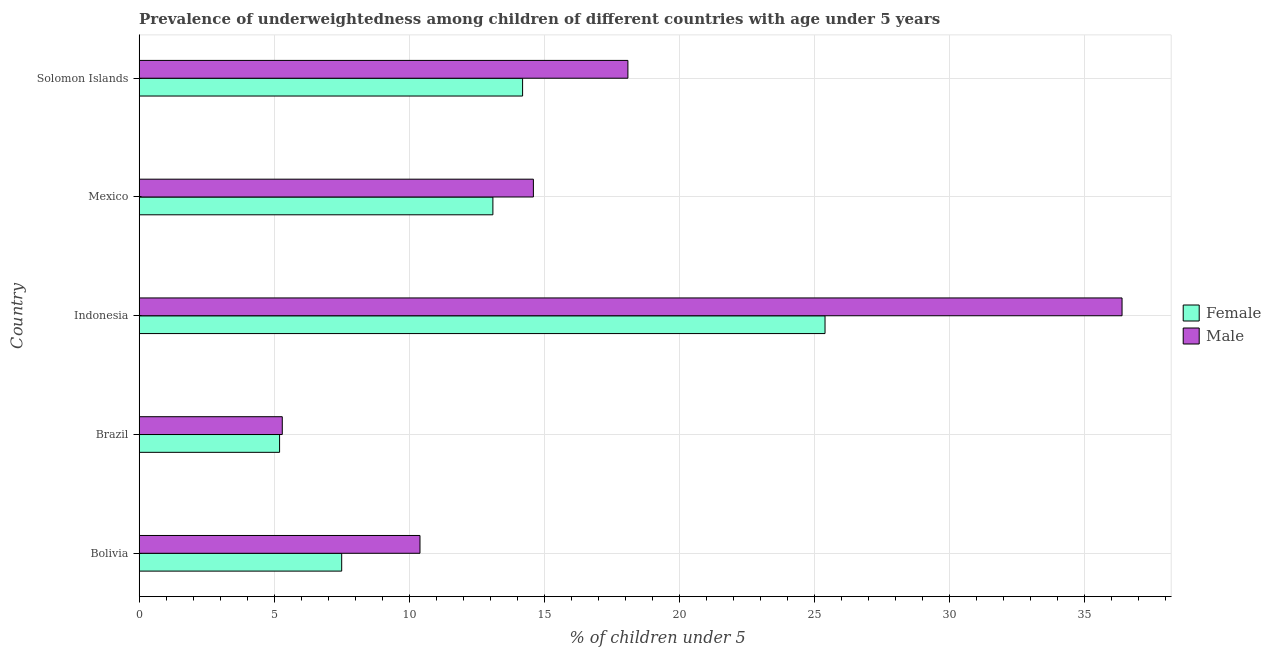Are the number of bars per tick equal to the number of legend labels?
Offer a terse response. Yes. Are the number of bars on each tick of the Y-axis equal?
Give a very brief answer. Yes. How many bars are there on the 1st tick from the top?
Ensure brevity in your answer.  2. How many bars are there on the 1st tick from the bottom?
Your answer should be compact. 2. In how many cases, is the number of bars for a given country not equal to the number of legend labels?
Ensure brevity in your answer.  0. What is the percentage of underweighted male children in Bolivia?
Make the answer very short. 10.4. Across all countries, what is the maximum percentage of underweighted male children?
Make the answer very short. 36.4. Across all countries, what is the minimum percentage of underweighted male children?
Provide a short and direct response. 5.3. What is the total percentage of underweighted female children in the graph?
Keep it short and to the point. 65.4. What is the difference between the percentage of underweighted male children in Mexico and the percentage of underweighted female children in Solomon Islands?
Offer a very short reply. 0.4. What is the average percentage of underweighted male children per country?
Offer a terse response. 16.96. In how many countries, is the percentage of underweighted male children greater than 34 %?
Keep it short and to the point. 1. What is the ratio of the percentage of underweighted female children in Bolivia to that in Brazil?
Ensure brevity in your answer.  1.44. Is the difference between the percentage of underweighted male children in Indonesia and Solomon Islands greater than the difference between the percentage of underweighted female children in Indonesia and Solomon Islands?
Your answer should be very brief. Yes. What is the difference between the highest and the second highest percentage of underweighted male children?
Your answer should be compact. 18.3. What is the difference between the highest and the lowest percentage of underweighted female children?
Your response must be concise. 20.2. In how many countries, is the percentage of underweighted male children greater than the average percentage of underweighted male children taken over all countries?
Give a very brief answer. 2. What does the 1st bar from the bottom in Indonesia represents?
Ensure brevity in your answer.  Female. How many bars are there?
Provide a succinct answer. 10. Are all the bars in the graph horizontal?
Provide a short and direct response. Yes. How many legend labels are there?
Offer a terse response. 2. What is the title of the graph?
Keep it short and to the point. Prevalence of underweightedness among children of different countries with age under 5 years. What is the label or title of the X-axis?
Make the answer very short.  % of children under 5. What is the  % of children under 5 of Male in Bolivia?
Offer a terse response. 10.4. What is the  % of children under 5 in Female in Brazil?
Your response must be concise. 5.2. What is the  % of children under 5 of Male in Brazil?
Your answer should be compact. 5.3. What is the  % of children under 5 of Female in Indonesia?
Your response must be concise. 25.4. What is the  % of children under 5 in Male in Indonesia?
Keep it short and to the point. 36.4. What is the  % of children under 5 in Female in Mexico?
Make the answer very short. 13.1. What is the  % of children under 5 of Male in Mexico?
Give a very brief answer. 14.6. What is the  % of children under 5 of Female in Solomon Islands?
Make the answer very short. 14.2. What is the  % of children under 5 in Male in Solomon Islands?
Your answer should be very brief. 18.1. Across all countries, what is the maximum  % of children under 5 of Female?
Give a very brief answer. 25.4. Across all countries, what is the maximum  % of children under 5 in Male?
Offer a very short reply. 36.4. Across all countries, what is the minimum  % of children under 5 of Female?
Your answer should be compact. 5.2. Across all countries, what is the minimum  % of children under 5 in Male?
Offer a terse response. 5.3. What is the total  % of children under 5 in Female in the graph?
Your answer should be compact. 65.4. What is the total  % of children under 5 in Male in the graph?
Offer a very short reply. 84.8. What is the difference between the  % of children under 5 in Female in Bolivia and that in Indonesia?
Your answer should be very brief. -17.9. What is the difference between the  % of children under 5 in Female in Bolivia and that in Solomon Islands?
Your answer should be very brief. -6.7. What is the difference between the  % of children under 5 in Male in Bolivia and that in Solomon Islands?
Offer a terse response. -7.7. What is the difference between the  % of children under 5 of Female in Brazil and that in Indonesia?
Provide a succinct answer. -20.2. What is the difference between the  % of children under 5 in Male in Brazil and that in Indonesia?
Give a very brief answer. -31.1. What is the difference between the  % of children under 5 in Female in Brazil and that in Mexico?
Give a very brief answer. -7.9. What is the difference between the  % of children under 5 in Male in Brazil and that in Mexico?
Your response must be concise. -9.3. What is the difference between the  % of children under 5 in Male in Brazil and that in Solomon Islands?
Offer a very short reply. -12.8. What is the difference between the  % of children under 5 in Male in Indonesia and that in Mexico?
Your answer should be compact. 21.8. What is the difference between the  % of children under 5 in Female in Indonesia and that in Solomon Islands?
Your answer should be very brief. 11.2. What is the difference between the  % of children under 5 in Male in Mexico and that in Solomon Islands?
Make the answer very short. -3.5. What is the difference between the  % of children under 5 in Female in Bolivia and the  % of children under 5 in Male in Indonesia?
Your answer should be compact. -28.9. What is the difference between the  % of children under 5 of Female in Bolivia and the  % of children under 5 of Male in Mexico?
Give a very brief answer. -7.1. What is the difference between the  % of children under 5 of Female in Brazil and the  % of children under 5 of Male in Indonesia?
Offer a very short reply. -31.2. What is the difference between the  % of children under 5 in Female in Mexico and the  % of children under 5 in Male in Solomon Islands?
Give a very brief answer. -5. What is the average  % of children under 5 of Female per country?
Give a very brief answer. 13.08. What is the average  % of children under 5 of Male per country?
Provide a short and direct response. 16.96. What is the difference between the  % of children under 5 of Female and  % of children under 5 of Male in Bolivia?
Provide a short and direct response. -2.9. What is the difference between the  % of children under 5 of Female and  % of children under 5 of Male in Indonesia?
Your response must be concise. -11. What is the difference between the  % of children under 5 of Female and  % of children under 5 of Male in Solomon Islands?
Keep it short and to the point. -3.9. What is the ratio of the  % of children under 5 of Female in Bolivia to that in Brazil?
Keep it short and to the point. 1.44. What is the ratio of the  % of children under 5 in Male in Bolivia to that in Brazil?
Offer a very short reply. 1.96. What is the ratio of the  % of children under 5 of Female in Bolivia to that in Indonesia?
Offer a terse response. 0.3. What is the ratio of the  % of children under 5 of Male in Bolivia to that in Indonesia?
Provide a short and direct response. 0.29. What is the ratio of the  % of children under 5 in Female in Bolivia to that in Mexico?
Make the answer very short. 0.57. What is the ratio of the  % of children under 5 in Male in Bolivia to that in Mexico?
Provide a short and direct response. 0.71. What is the ratio of the  % of children under 5 of Female in Bolivia to that in Solomon Islands?
Give a very brief answer. 0.53. What is the ratio of the  % of children under 5 in Male in Bolivia to that in Solomon Islands?
Offer a very short reply. 0.57. What is the ratio of the  % of children under 5 in Female in Brazil to that in Indonesia?
Keep it short and to the point. 0.2. What is the ratio of the  % of children under 5 of Male in Brazil to that in Indonesia?
Your response must be concise. 0.15. What is the ratio of the  % of children under 5 of Female in Brazil to that in Mexico?
Your answer should be very brief. 0.4. What is the ratio of the  % of children under 5 in Male in Brazil to that in Mexico?
Offer a very short reply. 0.36. What is the ratio of the  % of children under 5 of Female in Brazil to that in Solomon Islands?
Make the answer very short. 0.37. What is the ratio of the  % of children under 5 of Male in Brazil to that in Solomon Islands?
Provide a short and direct response. 0.29. What is the ratio of the  % of children under 5 in Female in Indonesia to that in Mexico?
Give a very brief answer. 1.94. What is the ratio of the  % of children under 5 of Male in Indonesia to that in Mexico?
Your response must be concise. 2.49. What is the ratio of the  % of children under 5 of Female in Indonesia to that in Solomon Islands?
Your answer should be compact. 1.79. What is the ratio of the  % of children under 5 in Male in Indonesia to that in Solomon Islands?
Your answer should be compact. 2.01. What is the ratio of the  % of children under 5 of Female in Mexico to that in Solomon Islands?
Offer a very short reply. 0.92. What is the ratio of the  % of children under 5 in Male in Mexico to that in Solomon Islands?
Offer a very short reply. 0.81. What is the difference between the highest and the second highest  % of children under 5 of Male?
Offer a very short reply. 18.3. What is the difference between the highest and the lowest  % of children under 5 of Female?
Offer a very short reply. 20.2. What is the difference between the highest and the lowest  % of children under 5 of Male?
Your answer should be very brief. 31.1. 